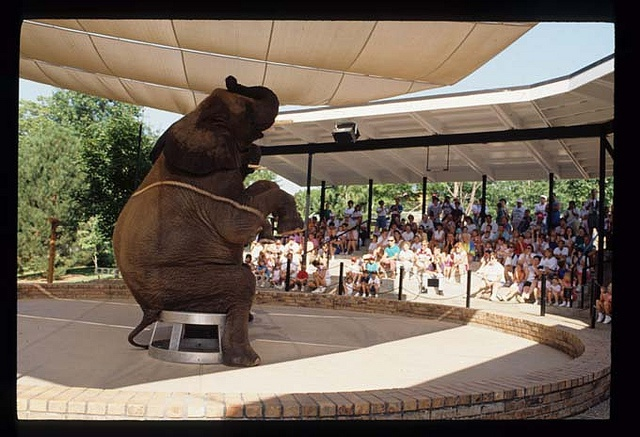Describe the objects in this image and their specific colors. I can see elephant in black, maroon, and gray tones, chair in black, gray, and darkgray tones, people in black, gray, and maroon tones, people in black, maroon, gray, and brown tones, and people in black, beige, lightblue, and tan tones in this image. 